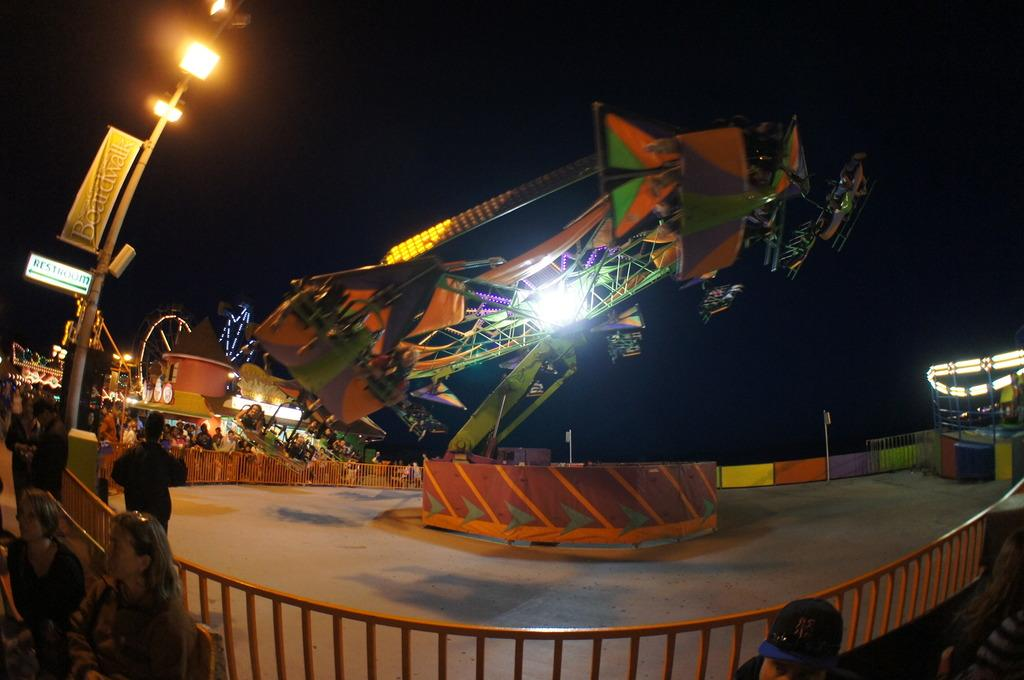What type of activity is depicted in the image? There is a fun ride in the image. Where are the people located in the image? The people wearing clothes are in the bottom left of the image. What can be seen on the left side of the image? There is a pole on the left side of the image. What type of whistle can be heard coming from the fun ride in the image? There is no whistle present in the image, and therefore no sound can be heard. 